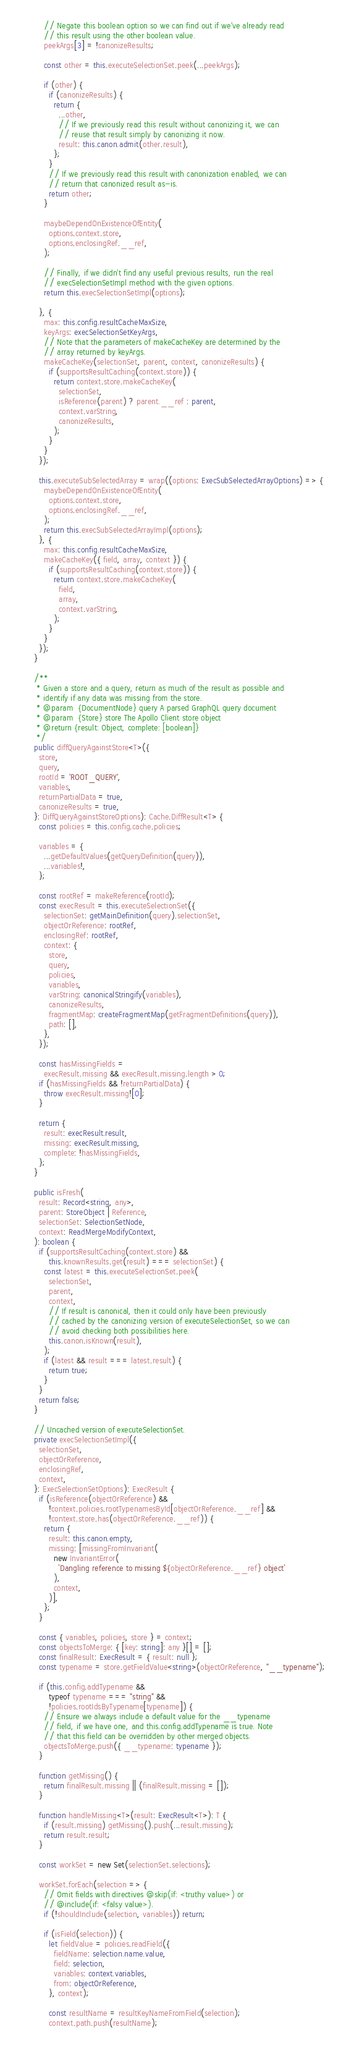<code> <loc_0><loc_0><loc_500><loc_500><_TypeScript_>      // Negate this boolean option so we can find out if we've already read
      // this result using the other boolean value.
      peekArgs[3] = !canonizeResults;

      const other = this.executeSelectionSet.peek(...peekArgs);

      if (other) {
        if (canonizeResults) {
          return {
            ...other,
            // If we previously read this result without canonizing it, we can
            // reuse that result simply by canonizing it now.
            result: this.canon.admit(other.result),
          };
        }
        // If we previously read this result with canonization enabled, we can
        // return that canonized result as-is.
        return other;
      }

      maybeDependOnExistenceOfEntity(
        options.context.store,
        options.enclosingRef.__ref,
      );

      // Finally, if we didn't find any useful previous results, run the real
      // execSelectionSetImpl method with the given options.
      return this.execSelectionSetImpl(options);

    }, {
      max: this.config.resultCacheMaxSize,
      keyArgs: execSelectionSetKeyArgs,
      // Note that the parameters of makeCacheKey are determined by the
      // array returned by keyArgs.
      makeCacheKey(selectionSet, parent, context, canonizeResults) {
        if (supportsResultCaching(context.store)) {
          return context.store.makeCacheKey(
            selectionSet,
            isReference(parent) ? parent.__ref : parent,
            context.varString,
            canonizeResults,
          );
        }
      }
    });

    this.executeSubSelectedArray = wrap((options: ExecSubSelectedArrayOptions) => {
      maybeDependOnExistenceOfEntity(
        options.context.store,
        options.enclosingRef.__ref,
      );
      return this.execSubSelectedArrayImpl(options);
    }, {
      max: this.config.resultCacheMaxSize,
      makeCacheKey({ field, array, context }) {
        if (supportsResultCaching(context.store)) {
          return context.store.makeCacheKey(
            field,
            array,
            context.varString,
          );
        }
      }
    });
  }

  /**
   * Given a store and a query, return as much of the result as possible and
   * identify if any data was missing from the store.
   * @param  {DocumentNode} query A parsed GraphQL query document
   * @param  {Store} store The Apollo Client store object
   * @return {result: Object, complete: [boolean]}
   */
  public diffQueryAgainstStore<T>({
    store,
    query,
    rootId = 'ROOT_QUERY',
    variables,
    returnPartialData = true,
    canonizeResults = true,
  }: DiffQueryAgainstStoreOptions): Cache.DiffResult<T> {
    const policies = this.config.cache.policies;

    variables = {
      ...getDefaultValues(getQueryDefinition(query)),
      ...variables!,
    };

    const rootRef = makeReference(rootId);
    const execResult = this.executeSelectionSet({
      selectionSet: getMainDefinition(query).selectionSet,
      objectOrReference: rootRef,
      enclosingRef: rootRef,
      context: {
        store,
        query,
        policies,
        variables,
        varString: canonicalStringify(variables),
        canonizeResults,
        fragmentMap: createFragmentMap(getFragmentDefinitions(query)),
        path: [],
      },
    });

    const hasMissingFields =
      execResult.missing && execResult.missing.length > 0;
    if (hasMissingFields && !returnPartialData) {
      throw execResult.missing![0];
    }

    return {
      result: execResult.result,
      missing: execResult.missing,
      complete: !hasMissingFields,
    };
  }

  public isFresh(
    result: Record<string, any>,
    parent: StoreObject | Reference,
    selectionSet: SelectionSetNode,
    context: ReadMergeModifyContext,
  ): boolean {
    if (supportsResultCaching(context.store) &&
        this.knownResults.get(result) === selectionSet) {
      const latest = this.executeSelectionSet.peek(
        selectionSet,
        parent,
        context,
        // If result is canonical, then it could only have been previously
        // cached by the canonizing version of executeSelectionSet, so we can
        // avoid checking both possibilities here.
        this.canon.isKnown(result),
      );
      if (latest && result === latest.result) {
        return true;
      }
    }
    return false;
  }

  // Uncached version of executeSelectionSet.
  private execSelectionSetImpl({
    selectionSet,
    objectOrReference,
    enclosingRef,
    context,
  }: ExecSelectionSetOptions): ExecResult {
    if (isReference(objectOrReference) &&
        !context.policies.rootTypenamesById[objectOrReference.__ref] &&
        !context.store.has(objectOrReference.__ref)) {
      return {
        result: this.canon.empty,
        missing: [missingFromInvariant(
          new InvariantError(
            `Dangling reference to missing ${objectOrReference.__ref} object`
          ),
          context,
        )],
      };
    }

    const { variables, policies, store } = context;
    const objectsToMerge: { [key: string]: any }[] = [];
    const finalResult: ExecResult = { result: null };
    const typename = store.getFieldValue<string>(objectOrReference, "__typename");

    if (this.config.addTypename &&
        typeof typename === "string" &&
        !policies.rootIdsByTypename[typename]) {
      // Ensure we always include a default value for the __typename
      // field, if we have one, and this.config.addTypename is true. Note
      // that this field can be overridden by other merged objects.
      objectsToMerge.push({ __typename: typename });
    }

    function getMissing() {
      return finalResult.missing || (finalResult.missing = []);
    }

    function handleMissing<T>(result: ExecResult<T>): T {
      if (result.missing) getMissing().push(...result.missing);
      return result.result;
    }

    const workSet = new Set(selectionSet.selections);

    workSet.forEach(selection => {
      // Omit fields with directives @skip(if: <truthy value>) or
      // @include(if: <falsy value>).
      if (!shouldInclude(selection, variables)) return;

      if (isField(selection)) {
        let fieldValue = policies.readField({
          fieldName: selection.name.value,
          field: selection,
          variables: context.variables,
          from: objectOrReference,
        }, context);

        const resultName = resultKeyNameFromField(selection);
        context.path.push(resultName);
</code> 